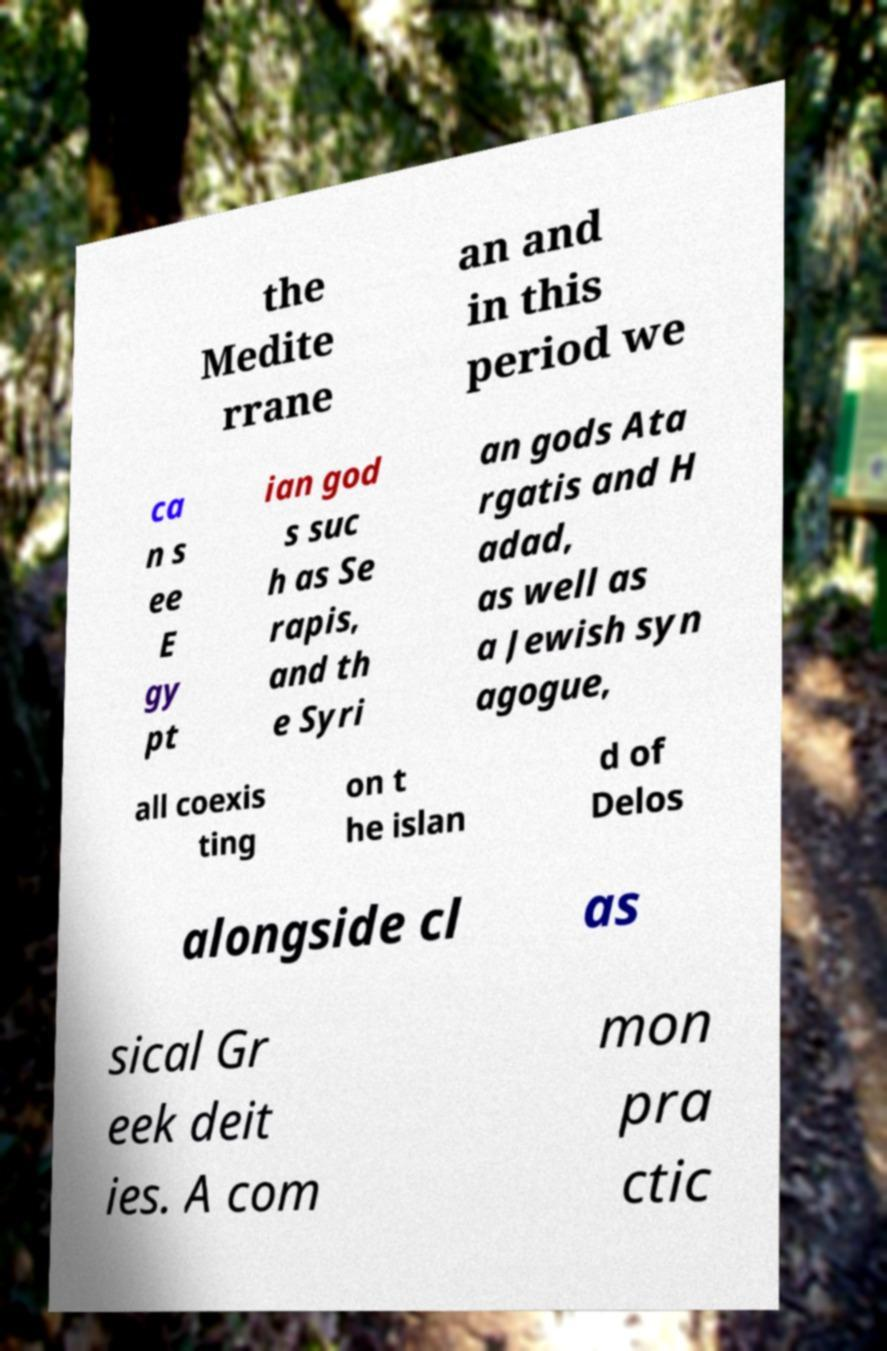Can you accurately transcribe the text from the provided image for me? the Medite rrane an and in this period we ca n s ee E gy pt ian god s suc h as Se rapis, and th e Syri an gods Ata rgatis and H adad, as well as a Jewish syn agogue, all coexis ting on t he islan d of Delos alongside cl as sical Gr eek deit ies. A com mon pra ctic 